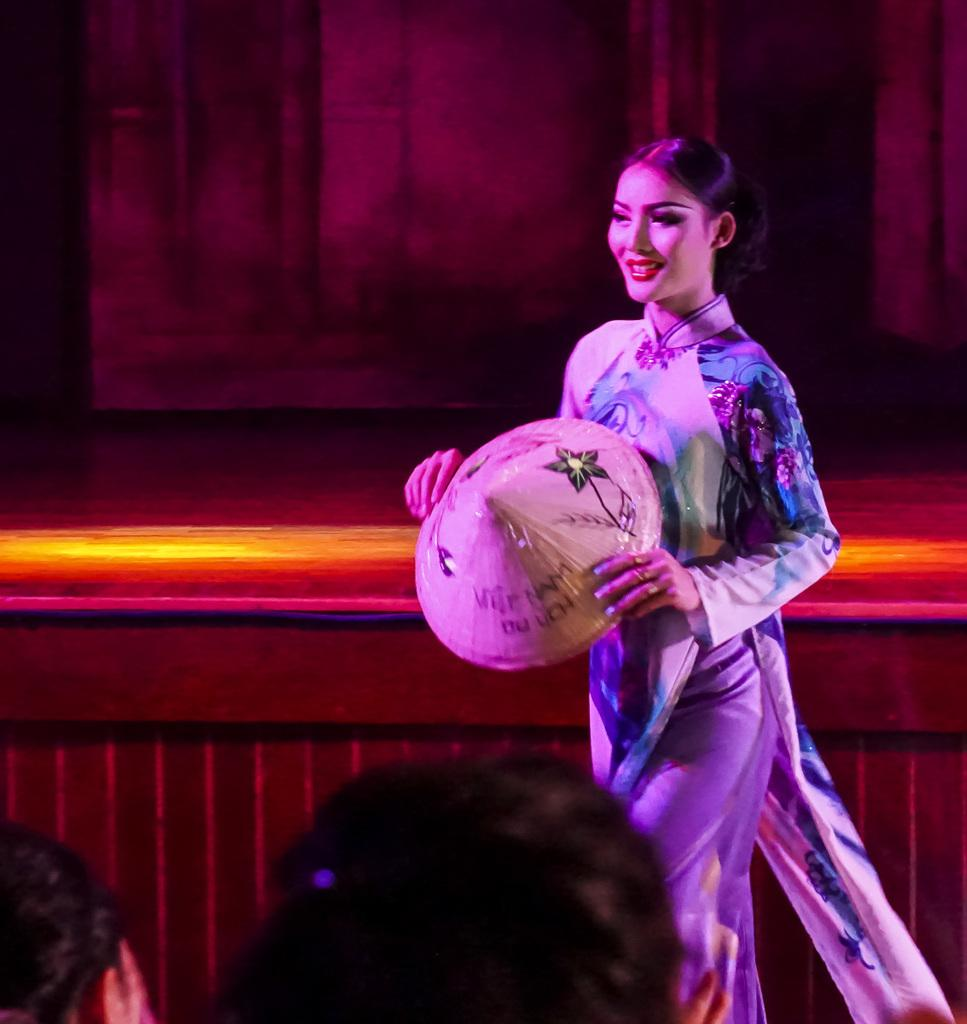Who is present in the image? There is a woman in the image. What is the woman holding? The woman is holding a hat. What is the woman doing in the image? The woman is walking. How many people are visible in the foreground of the image? There are two heads visible in the foreground of the image. What can be seen in the background of the image? There is a stage in the background of the image. What is present at the top of the image? There are curtains at the top of the image. Can you see the receipt for the hat purchase in the image? There is no receipt visible in the image. Is there any smoke coming from the stage in the image? There is no smoke present in the image. 